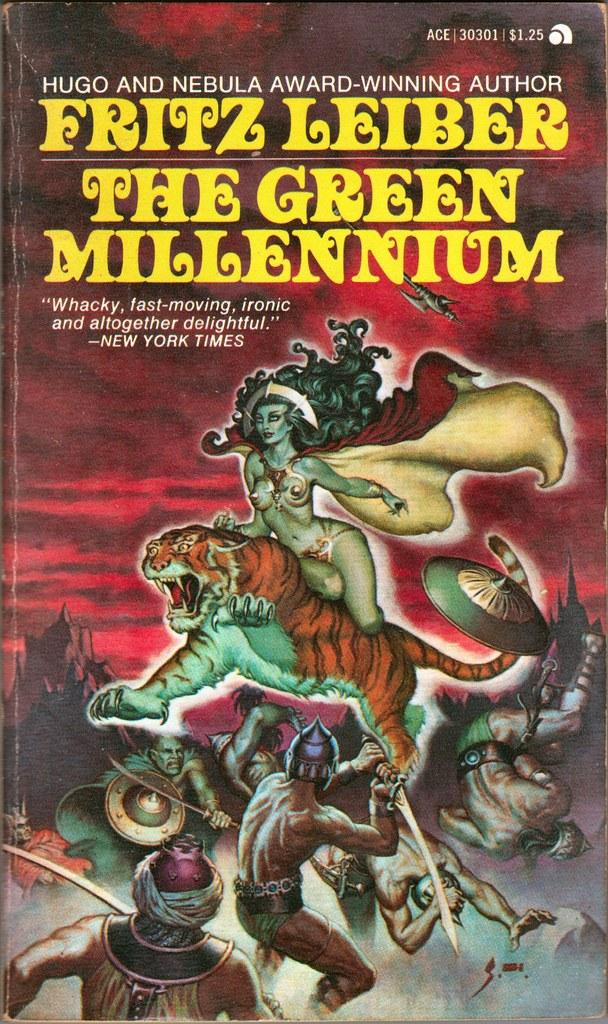<image>
Present a compact description of the photo's key features. A book cover from the award-winning author Fritz Leiber. 